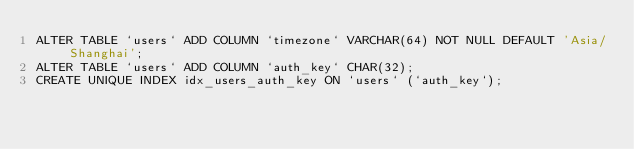Convert code to text. <code><loc_0><loc_0><loc_500><loc_500><_SQL_>ALTER TABLE `users` ADD COLUMN `timezone` VARCHAR(64) NOT NULL DEFAULT 'Asia/Shanghai';
ALTER TABLE `users` ADD COLUMN `auth_key` CHAR(32);
CREATE UNIQUE INDEX idx_users_auth_key ON `users` (`auth_key`);
</code> 